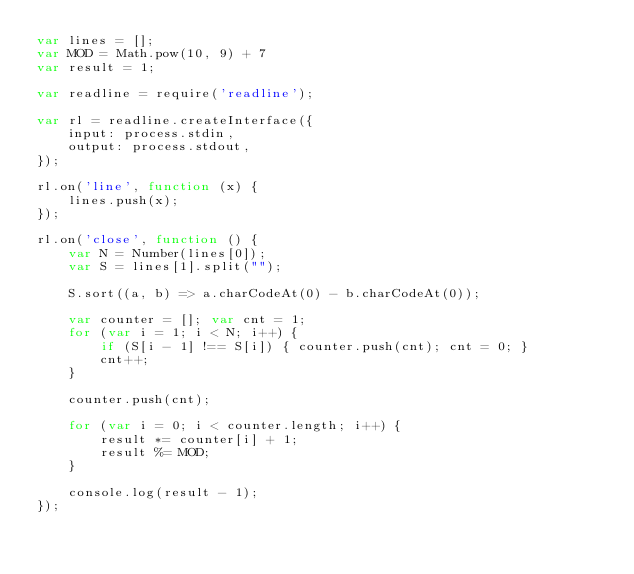<code> <loc_0><loc_0><loc_500><loc_500><_JavaScript_>var lines = [];
var MOD = Math.pow(10, 9) + 7
var result = 1;

var readline = require('readline');

var rl = readline.createInterface({
    input: process.stdin,
    output: process.stdout,
});

rl.on('line', function (x) {
    lines.push(x);
});

rl.on('close', function () {
    var N = Number(lines[0]);
    var S = lines[1].split("");

    S.sort((a, b) => a.charCodeAt(0) - b.charCodeAt(0));

    var counter = []; var cnt = 1;
    for (var i = 1; i < N; i++) {
        if (S[i - 1] !== S[i]) { counter.push(cnt); cnt = 0; }
        cnt++;
    }

    counter.push(cnt);

    for (var i = 0; i < counter.length; i++) {
        result *= counter[i] + 1;
        result %= MOD;
    }

    console.log(result - 1);
});</code> 